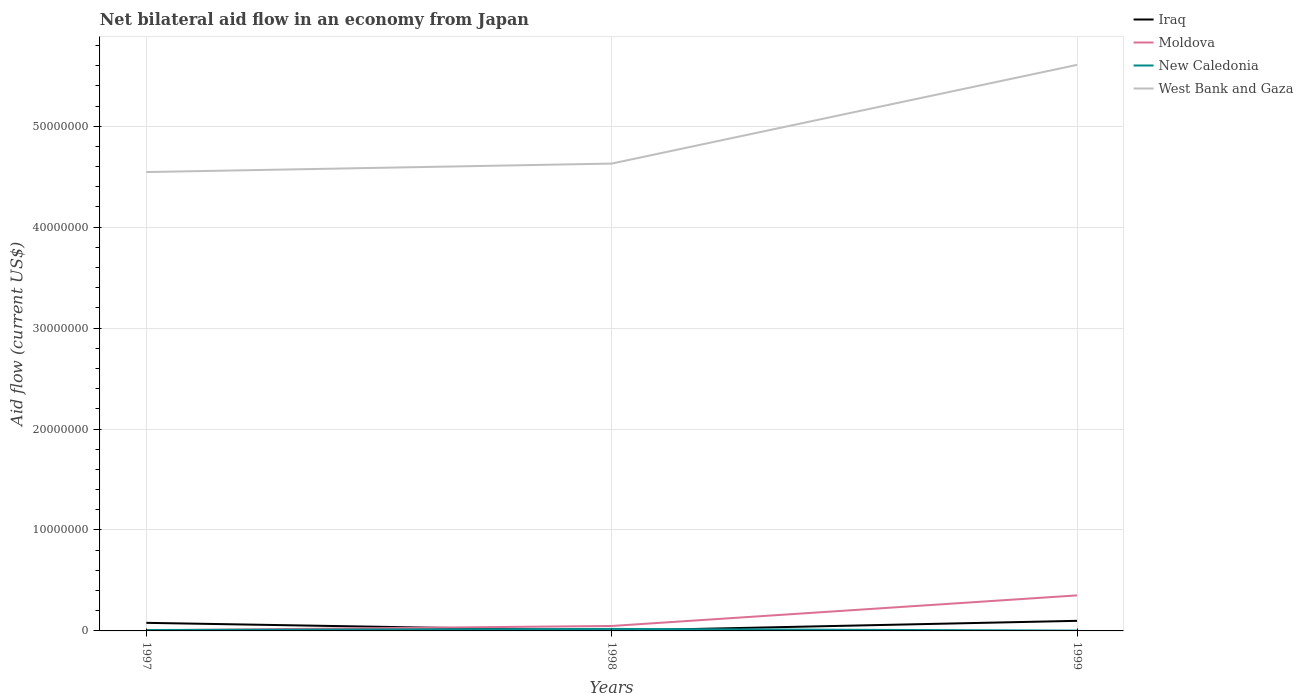How many different coloured lines are there?
Offer a very short reply. 4. Across all years, what is the maximum net bilateral aid flow in West Bank and Gaza?
Your answer should be very brief. 4.55e+07. What is the total net bilateral aid flow in New Caledonia in the graph?
Your answer should be very brief. 1.70e+05. What is the difference between the highest and the second highest net bilateral aid flow in West Bank and Gaza?
Ensure brevity in your answer.  1.06e+07. What is the difference between the highest and the lowest net bilateral aid flow in West Bank and Gaza?
Give a very brief answer. 1. How many lines are there?
Provide a succinct answer. 4. How many years are there in the graph?
Make the answer very short. 3. What is the difference between two consecutive major ticks on the Y-axis?
Offer a terse response. 1.00e+07. Are the values on the major ticks of Y-axis written in scientific E-notation?
Give a very brief answer. No. Does the graph contain any zero values?
Your answer should be very brief. No. Does the graph contain grids?
Your answer should be very brief. Yes. How many legend labels are there?
Your response must be concise. 4. How are the legend labels stacked?
Make the answer very short. Vertical. What is the title of the graph?
Give a very brief answer. Net bilateral aid flow in an economy from Japan. Does "Sudan" appear as one of the legend labels in the graph?
Your answer should be compact. No. What is the label or title of the X-axis?
Your answer should be very brief. Years. What is the label or title of the Y-axis?
Make the answer very short. Aid flow (current US$). What is the Aid flow (current US$) of New Caledonia in 1997?
Ensure brevity in your answer.  9.00e+04. What is the Aid flow (current US$) of West Bank and Gaza in 1997?
Ensure brevity in your answer.  4.55e+07. What is the Aid flow (current US$) in Iraq in 1998?
Your answer should be very brief. 2.00e+04. What is the Aid flow (current US$) in Moldova in 1998?
Your response must be concise. 4.90e+05. What is the Aid flow (current US$) of West Bank and Gaza in 1998?
Give a very brief answer. 4.63e+07. What is the Aid flow (current US$) of Iraq in 1999?
Offer a terse response. 1.00e+06. What is the Aid flow (current US$) of Moldova in 1999?
Your response must be concise. 3.52e+06. What is the Aid flow (current US$) in West Bank and Gaza in 1999?
Your answer should be very brief. 5.61e+07. Across all years, what is the maximum Aid flow (current US$) of Iraq?
Your answer should be compact. 1.00e+06. Across all years, what is the maximum Aid flow (current US$) in Moldova?
Offer a terse response. 3.52e+06. Across all years, what is the maximum Aid flow (current US$) in West Bank and Gaza?
Your answer should be compact. 5.61e+07. Across all years, what is the minimum Aid flow (current US$) in Moldova?
Your response must be concise. 6.00e+04. Across all years, what is the minimum Aid flow (current US$) in West Bank and Gaza?
Ensure brevity in your answer.  4.55e+07. What is the total Aid flow (current US$) in Iraq in the graph?
Give a very brief answer. 1.82e+06. What is the total Aid flow (current US$) of Moldova in the graph?
Provide a succinct answer. 4.07e+06. What is the total Aid flow (current US$) in West Bank and Gaza in the graph?
Your response must be concise. 1.48e+08. What is the difference between the Aid flow (current US$) in Iraq in 1997 and that in 1998?
Your response must be concise. 7.80e+05. What is the difference between the Aid flow (current US$) of Moldova in 1997 and that in 1998?
Offer a very short reply. -4.30e+05. What is the difference between the Aid flow (current US$) in New Caledonia in 1997 and that in 1998?
Provide a succinct answer. -1.10e+05. What is the difference between the Aid flow (current US$) in West Bank and Gaza in 1997 and that in 1998?
Your answer should be compact. -8.40e+05. What is the difference between the Aid flow (current US$) of Iraq in 1997 and that in 1999?
Your response must be concise. -2.00e+05. What is the difference between the Aid flow (current US$) of Moldova in 1997 and that in 1999?
Ensure brevity in your answer.  -3.46e+06. What is the difference between the Aid flow (current US$) of West Bank and Gaza in 1997 and that in 1999?
Offer a very short reply. -1.06e+07. What is the difference between the Aid flow (current US$) in Iraq in 1998 and that in 1999?
Give a very brief answer. -9.80e+05. What is the difference between the Aid flow (current US$) in Moldova in 1998 and that in 1999?
Provide a short and direct response. -3.03e+06. What is the difference between the Aid flow (current US$) in West Bank and Gaza in 1998 and that in 1999?
Keep it short and to the point. -9.78e+06. What is the difference between the Aid flow (current US$) of Iraq in 1997 and the Aid flow (current US$) of West Bank and Gaza in 1998?
Provide a short and direct response. -4.55e+07. What is the difference between the Aid flow (current US$) of Moldova in 1997 and the Aid flow (current US$) of New Caledonia in 1998?
Provide a succinct answer. -1.40e+05. What is the difference between the Aid flow (current US$) in Moldova in 1997 and the Aid flow (current US$) in West Bank and Gaza in 1998?
Offer a terse response. -4.62e+07. What is the difference between the Aid flow (current US$) of New Caledonia in 1997 and the Aid flow (current US$) of West Bank and Gaza in 1998?
Give a very brief answer. -4.62e+07. What is the difference between the Aid flow (current US$) in Iraq in 1997 and the Aid flow (current US$) in Moldova in 1999?
Offer a terse response. -2.72e+06. What is the difference between the Aid flow (current US$) in Iraq in 1997 and the Aid flow (current US$) in New Caledonia in 1999?
Provide a succinct answer. 7.70e+05. What is the difference between the Aid flow (current US$) in Iraq in 1997 and the Aid flow (current US$) in West Bank and Gaza in 1999?
Give a very brief answer. -5.53e+07. What is the difference between the Aid flow (current US$) in Moldova in 1997 and the Aid flow (current US$) in New Caledonia in 1999?
Provide a succinct answer. 3.00e+04. What is the difference between the Aid flow (current US$) in Moldova in 1997 and the Aid flow (current US$) in West Bank and Gaza in 1999?
Ensure brevity in your answer.  -5.60e+07. What is the difference between the Aid flow (current US$) in New Caledonia in 1997 and the Aid flow (current US$) in West Bank and Gaza in 1999?
Your answer should be compact. -5.60e+07. What is the difference between the Aid flow (current US$) in Iraq in 1998 and the Aid flow (current US$) in Moldova in 1999?
Offer a terse response. -3.50e+06. What is the difference between the Aid flow (current US$) in Iraq in 1998 and the Aid flow (current US$) in West Bank and Gaza in 1999?
Make the answer very short. -5.61e+07. What is the difference between the Aid flow (current US$) in Moldova in 1998 and the Aid flow (current US$) in West Bank and Gaza in 1999?
Make the answer very short. -5.56e+07. What is the difference between the Aid flow (current US$) of New Caledonia in 1998 and the Aid flow (current US$) of West Bank and Gaza in 1999?
Provide a succinct answer. -5.59e+07. What is the average Aid flow (current US$) in Iraq per year?
Ensure brevity in your answer.  6.07e+05. What is the average Aid flow (current US$) in Moldova per year?
Ensure brevity in your answer.  1.36e+06. What is the average Aid flow (current US$) of New Caledonia per year?
Make the answer very short. 1.07e+05. What is the average Aid flow (current US$) of West Bank and Gaza per year?
Your answer should be compact. 4.93e+07. In the year 1997, what is the difference between the Aid flow (current US$) in Iraq and Aid flow (current US$) in Moldova?
Offer a terse response. 7.40e+05. In the year 1997, what is the difference between the Aid flow (current US$) in Iraq and Aid flow (current US$) in New Caledonia?
Provide a short and direct response. 7.10e+05. In the year 1997, what is the difference between the Aid flow (current US$) of Iraq and Aid flow (current US$) of West Bank and Gaza?
Provide a short and direct response. -4.47e+07. In the year 1997, what is the difference between the Aid flow (current US$) of Moldova and Aid flow (current US$) of West Bank and Gaza?
Your answer should be compact. -4.54e+07. In the year 1997, what is the difference between the Aid flow (current US$) of New Caledonia and Aid flow (current US$) of West Bank and Gaza?
Make the answer very short. -4.54e+07. In the year 1998, what is the difference between the Aid flow (current US$) of Iraq and Aid flow (current US$) of Moldova?
Make the answer very short. -4.70e+05. In the year 1998, what is the difference between the Aid flow (current US$) in Iraq and Aid flow (current US$) in West Bank and Gaza?
Your response must be concise. -4.63e+07. In the year 1998, what is the difference between the Aid flow (current US$) in Moldova and Aid flow (current US$) in West Bank and Gaza?
Your answer should be compact. -4.58e+07. In the year 1998, what is the difference between the Aid flow (current US$) of New Caledonia and Aid flow (current US$) of West Bank and Gaza?
Provide a short and direct response. -4.61e+07. In the year 1999, what is the difference between the Aid flow (current US$) in Iraq and Aid flow (current US$) in Moldova?
Offer a very short reply. -2.52e+06. In the year 1999, what is the difference between the Aid flow (current US$) in Iraq and Aid flow (current US$) in New Caledonia?
Ensure brevity in your answer.  9.70e+05. In the year 1999, what is the difference between the Aid flow (current US$) of Iraq and Aid flow (current US$) of West Bank and Gaza?
Ensure brevity in your answer.  -5.51e+07. In the year 1999, what is the difference between the Aid flow (current US$) in Moldova and Aid flow (current US$) in New Caledonia?
Your answer should be very brief. 3.49e+06. In the year 1999, what is the difference between the Aid flow (current US$) of Moldova and Aid flow (current US$) of West Bank and Gaza?
Provide a short and direct response. -5.26e+07. In the year 1999, what is the difference between the Aid flow (current US$) of New Caledonia and Aid flow (current US$) of West Bank and Gaza?
Provide a succinct answer. -5.60e+07. What is the ratio of the Aid flow (current US$) of Iraq in 1997 to that in 1998?
Your answer should be very brief. 40. What is the ratio of the Aid flow (current US$) in Moldova in 1997 to that in 1998?
Your answer should be compact. 0.12. What is the ratio of the Aid flow (current US$) of New Caledonia in 1997 to that in 1998?
Ensure brevity in your answer.  0.45. What is the ratio of the Aid flow (current US$) in West Bank and Gaza in 1997 to that in 1998?
Ensure brevity in your answer.  0.98. What is the ratio of the Aid flow (current US$) in Iraq in 1997 to that in 1999?
Make the answer very short. 0.8. What is the ratio of the Aid flow (current US$) of Moldova in 1997 to that in 1999?
Provide a succinct answer. 0.02. What is the ratio of the Aid flow (current US$) in West Bank and Gaza in 1997 to that in 1999?
Provide a succinct answer. 0.81. What is the ratio of the Aid flow (current US$) of Iraq in 1998 to that in 1999?
Your response must be concise. 0.02. What is the ratio of the Aid flow (current US$) in Moldova in 1998 to that in 1999?
Provide a short and direct response. 0.14. What is the ratio of the Aid flow (current US$) of New Caledonia in 1998 to that in 1999?
Make the answer very short. 6.67. What is the ratio of the Aid flow (current US$) of West Bank and Gaza in 1998 to that in 1999?
Provide a succinct answer. 0.83. What is the difference between the highest and the second highest Aid flow (current US$) in Iraq?
Your answer should be very brief. 2.00e+05. What is the difference between the highest and the second highest Aid flow (current US$) in Moldova?
Ensure brevity in your answer.  3.03e+06. What is the difference between the highest and the second highest Aid flow (current US$) of New Caledonia?
Provide a succinct answer. 1.10e+05. What is the difference between the highest and the second highest Aid flow (current US$) of West Bank and Gaza?
Ensure brevity in your answer.  9.78e+06. What is the difference between the highest and the lowest Aid flow (current US$) in Iraq?
Provide a short and direct response. 9.80e+05. What is the difference between the highest and the lowest Aid flow (current US$) of Moldova?
Your answer should be compact. 3.46e+06. What is the difference between the highest and the lowest Aid flow (current US$) of New Caledonia?
Provide a succinct answer. 1.70e+05. What is the difference between the highest and the lowest Aid flow (current US$) in West Bank and Gaza?
Your answer should be very brief. 1.06e+07. 